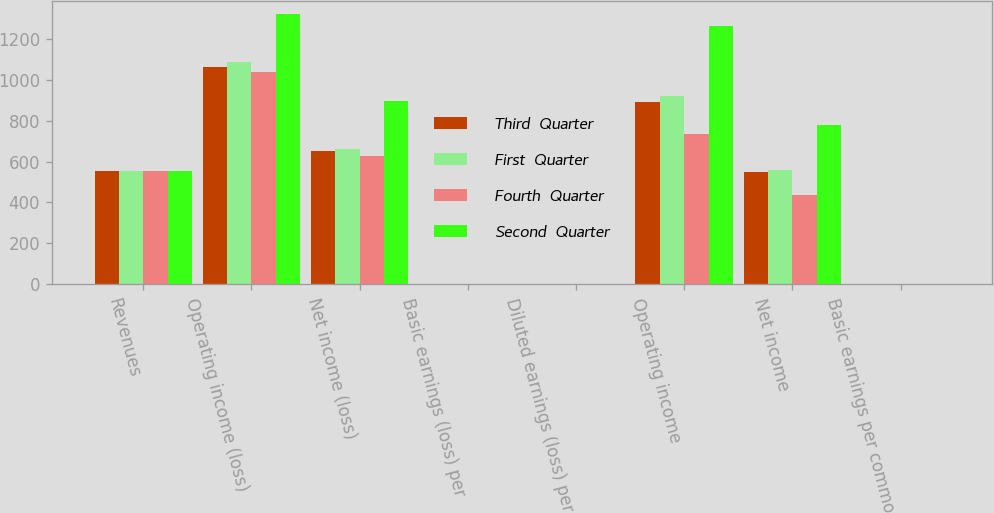<chart> <loc_0><loc_0><loc_500><loc_500><stacked_bar_chart><ecel><fcel>Revenues<fcel>Operating income (loss)<fcel>Net income (loss)<fcel>Basic earnings (loss) per<fcel>Diluted earnings (loss) per<fcel>Operating income<fcel>Net income<fcel>Basic earnings per common<nl><fcel>Third  Quarter<fcel>553.5<fcel>1062<fcel>653<fcel>2.29<fcel>2.26<fcel>891<fcel>548<fcel>1.73<nl><fcel>First  Quarter<fcel>553.5<fcel>1088<fcel>663<fcel>2.34<fcel>2.31<fcel>923<fcel>559<fcel>1.77<nl><fcel>Fourth  Quarter<fcel>553.5<fcel>1038<fcel>628<fcel>2.21<fcel>2.18<fcel>737<fcel>437<fcel>1.44<nl><fcel>Second  Quarter<fcel>553.5<fcel>1321<fcel>895<fcel>3.16<fcel>3.16<fcel>1264<fcel>780<fcel>2.66<nl></chart> 